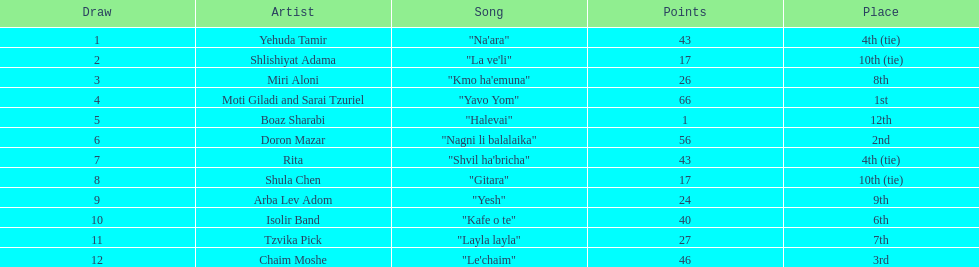Which song accumulated the highest number of points? "Yavo Yom". 